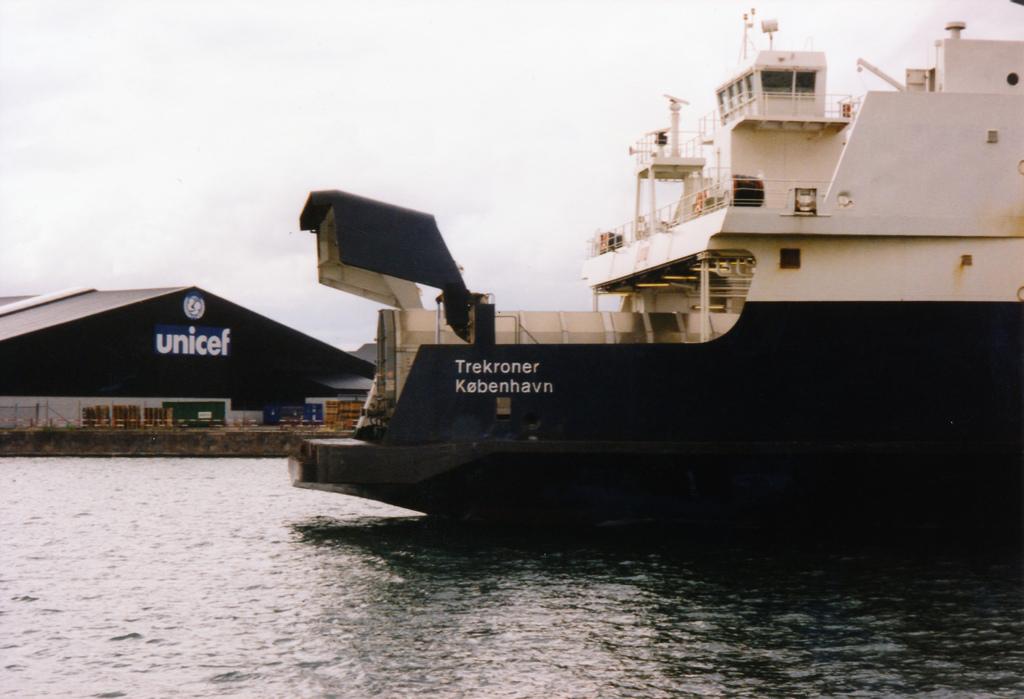What company works in that building?
Provide a succinct answer. Unicef. What is the name of the boat?
Ensure brevity in your answer.  Trekroner kobenhavn. 